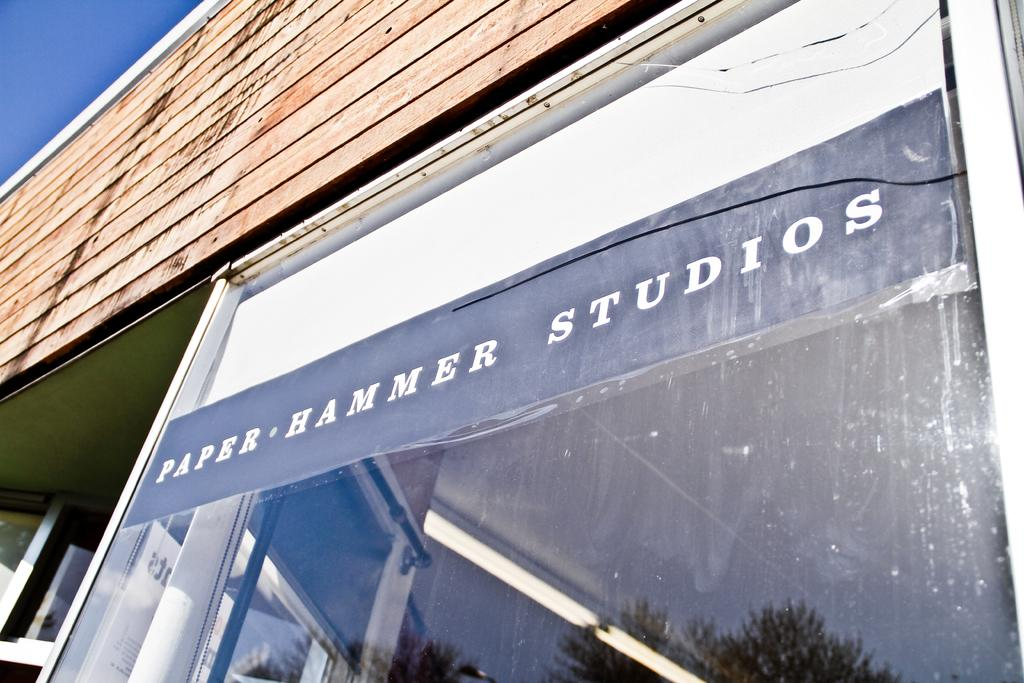What type of structure is visible in the image? There is a wall of a building in the image. What feature can be seen on the wall? The wall has a glass door. What is written or displayed on the glass door? There is text visible on the glass. What can be seen in the reflections on the glass door? The reflections on the glass door show the surroundings, including the sky. What part of the natural environment is visible in the image? The sky is visible in the image. What type of wound can be seen on the throat of the person in the image? There is no person present in the image, and therefore no wound or throat can be observed. 